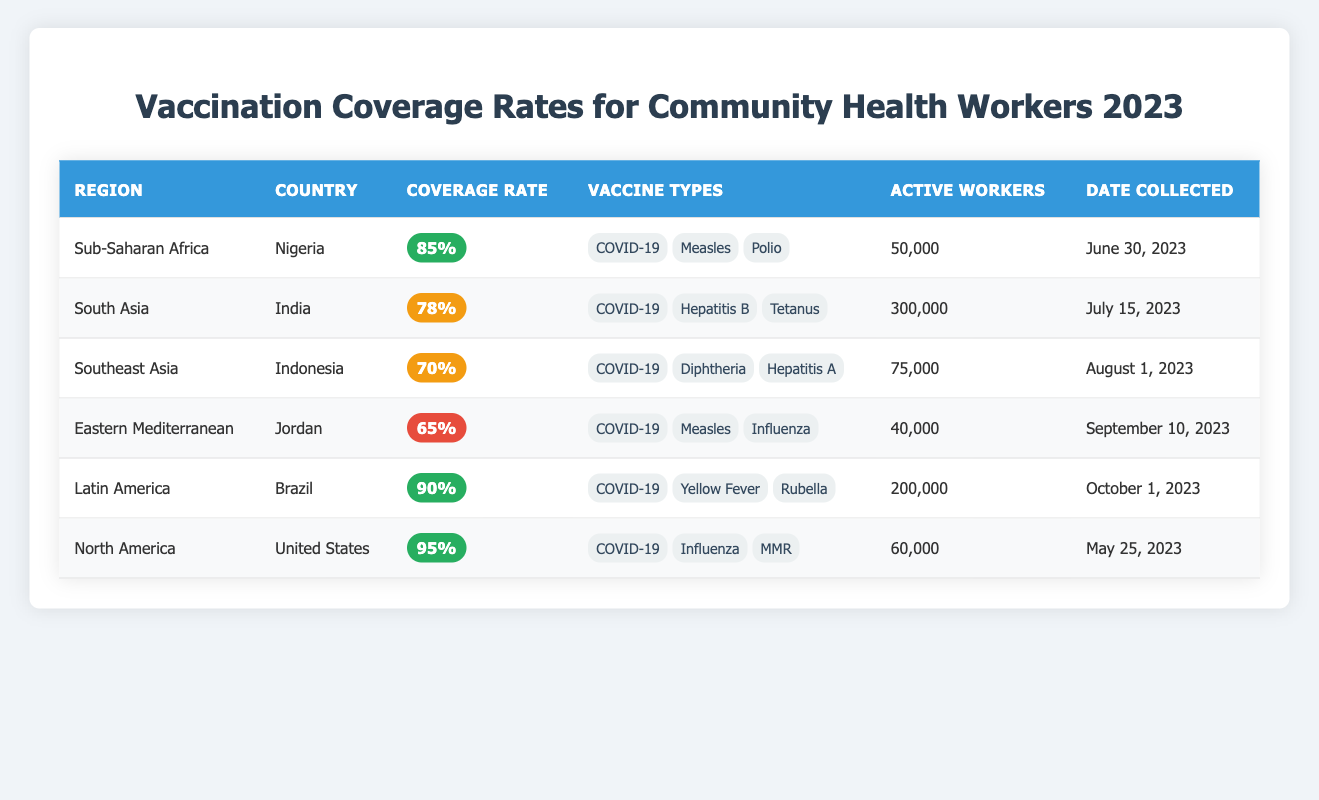What is the vaccination coverage rate in Brazil? The table lists Brazil's coverage rate as 90%.
Answer: 90% Which country has the highest vaccination coverage rate? According to the table, the United States has the highest coverage rate at 95%.
Answer: United States How many active community health workers are there in India? The table indicates that India has 300,000 active community health workers.
Answer: 300,000 What is the average vaccination coverage rate of all countries listed in the table? To find the average, we sum the coverage rates: (85 + 78 + 70 + 65 + 90 + 95) = 483. There are 6 countries, so the average is 483 / 6 = 80.5.
Answer: 80.5 Is the vaccination coverage rate in Jordan greater than 70%? The table states that Jordan's coverage rate is 65%, which is less than 70%.
Answer: No How many more active workers does India have compared to Jordan? India has 300,000 active workers, while Jordan has 40,000. The difference is 300,000 - 40,000 = 260,000.
Answer: 260,000 What percentage of coverage rates in the table are considered high (above 80%)? The high coverage rates are 85% (Nigeria), 90% (Brazil), and 95% (United States). That's 3 out of 6 countries, which gives us (3/6) * 100 = 50%.
Answer: 50% Which region has the lowest vaccination coverage rate? The table shows that the Eastern Mediterranean region (Jordan) has the lowest rate at 65%.
Answer: Eastern Mediterranean How many total active community health workers are reported across all countries? By adding the active workers: 50,000 (Nigeria) + 300,000 (India) + 75,000 (Indonesia) + 40,000 (Jordan) + 200,000 (Brazil) + 60,000 (United States) = 725,000.
Answer: 725,000 Are any of the countries tracking coverage rates less than 70%? The table indicates that Indonesia (70%) is the only country below 70% coverage.
Answer: Yes 